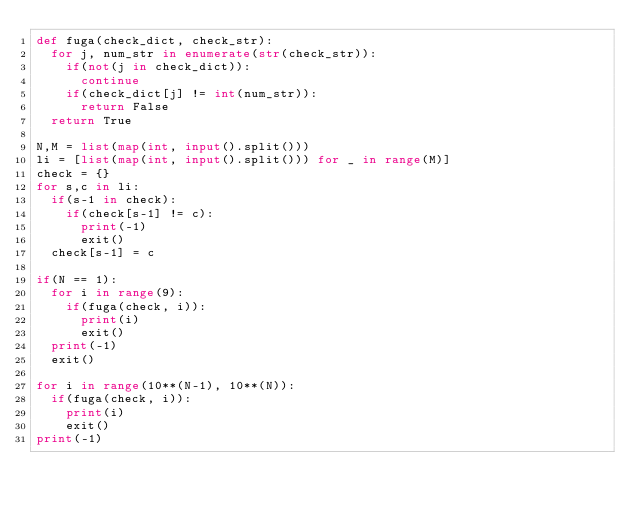<code> <loc_0><loc_0><loc_500><loc_500><_Python_>def fuga(check_dict, check_str):
  for j, num_str in enumerate(str(check_str)):
    if(not(j in check_dict)):
      continue
    if(check_dict[j] != int(num_str)):
      return False
  return True

N,M = list(map(int, input().split()))
li = [list(map(int, input().split())) for _ in range(M)]
check = {}
for s,c in li:
  if(s-1 in check):
    if(check[s-1] != c):
      print(-1)
      exit()
  check[s-1] = c

if(N == 1):
  for i in range(9):
    if(fuga(check, i)):
      print(i)
      exit()
  print(-1)
  exit()

for i in range(10**(N-1), 10**(N)):
  if(fuga(check, i)):
    print(i)
    exit()
print(-1)
</code> 